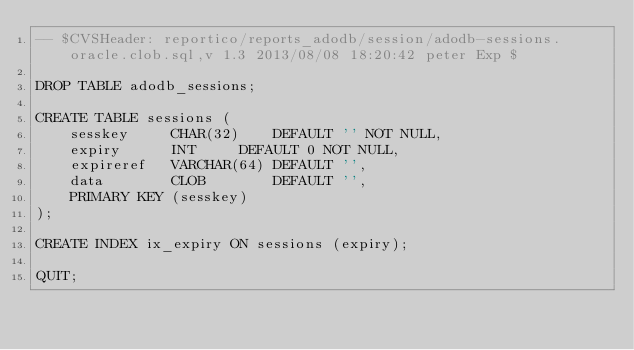Convert code to text. <code><loc_0><loc_0><loc_500><loc_500><_SQL_>-- $CVSHeader: reportico/reports_adodb/session/adodb-sessions.oracle.clob.sql,v 1.3 2013/08/08 18:20:42 peter Exp $

DROP TABLE adodb_sessions;

CREATE TABLE sessions (
	sesskey		CHAR(32)	DEFAULT '' NOT NULL,
	expiry		INT		DEFAULT 0 NOT NULL,
	expireref	VARCHAR(64)	DEFAULT '',
	data		CLOB		DEFAULT '',
	PRIMARY KEY	(sesskey)
);

CREATE INDEX ix_expiry ON sessions (expiry);

QUIT;
</code> 